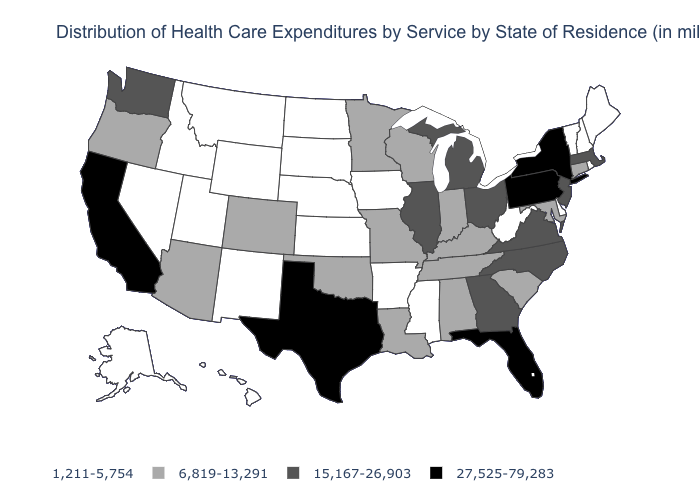What is the value of Mississippi?
Give a very brief answer. 1,211-5,754. What is the value of New Hampshire?
Write a very short answer. 1,211-5,754. What is the value of Utah?
Concise answer only. 1,211-5,754. What is the value of New Mexico?
Give a very brief answer. 1,211-5,754. What is the value of Connecticut?
Be succinct. 6,819-13,291. Name the states that have a value in the range 6,819-13,291?
Short answer required. Alabama, Arizona, Colorado, Connecticut, Indiana, Kentucky, Louisiana, Maryland, Minnesota, Missouri, Oklahoma, Oregon, South Carolina, Tennessee, Wisconsin. Which states have the highest value in the USA?
Be succinct. California, Florida, New York, Pennsylvania, Texas. Name the states that have a value in the range 1,211-5,754?
Keep it brief. Alaska, Arkansas, Delaware, Hawaii, Idaho, Iowa, Kansas, Maine, Mississippi, Montana, Nebraska, Nevada, New Hampshire, New Mexico, North Dakota, Rhode Island, South Dakota, Utah, Vermont, West Virginia, Wyoming. What is the value of West Virginia?
Be succinct. 1,211-5,754. Name the states that have a value in the range 1,211-5,754?
Give a very brief answer. Alaska, Arkansas, Delaware, Hawaii, Idaho, Iowa, Kansas, Maine, Mississippi, Montana, Nebraska, Nevada, New Hampshire, New Mexico, North Dakota, Rhode Island, South Dakota, Utah, Vermont, West Virginia, Wyoming. Is the legend a continuous bar?
Short answer required. No. What is the lowest value in states that border North Dakota?
Keep it brief. 1,211-5,754. What is the value of Arkansas?
Quick response, please. 1,211-5,754. What is the lowest value in the USA?
Quick response, please. 1,211-5,754. Does Tennessee have a lower value than New Jersey?
Write a very short answer. Yes. 